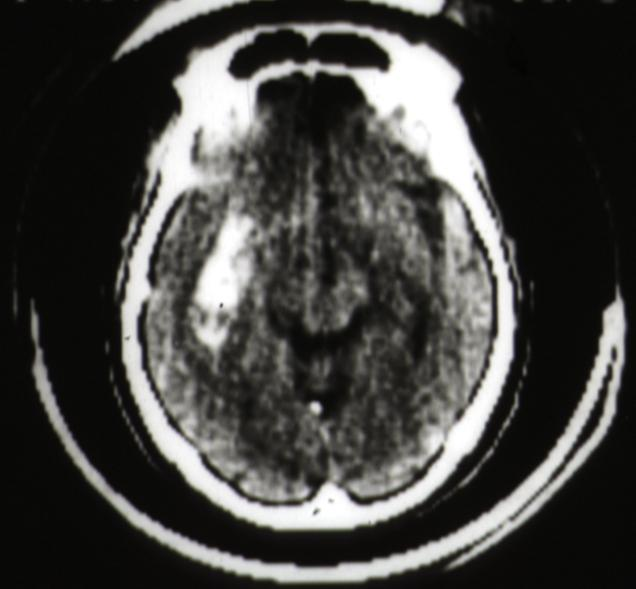what does cat scan?
Answer the question using a single word or phrase. Putamen hemorrhage 